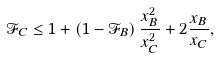Convert formula to latex. <formula><loc_0><loc_0><loc_500><loc_500>\mathcal { F } _ { C } \leq 1 + \left ( 1 - \mathcal { F } _ { B } \right ) \frac { x _ { B } ^ { 2 } } { x _ { C } ^ { 2 } } + 2 \frac { x _ { B } } { x _ { C } } ,</formula> 